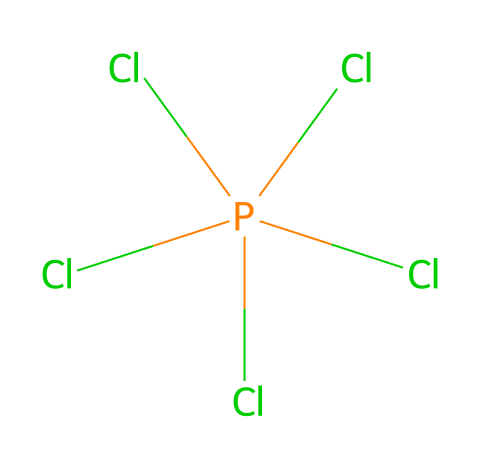What is the molecular formula of phosphorus pentachloride? The SMILES representation indicates that there is one phosphorus atom and five chlorine atoms. Therefore, the molecular formula is derived from counting these atoms.
Answer: PCl5 How many chlorine atoms are attached to the phosphorus atom? By analyzing the structure given in the SMILES notation, the phosphorus atom is bonded to five chlorine atoms, which can be seen through the representation.
Answer: five What type of hybridization does the phosphorus atom exhibit? Phosphorus in PCl5 undergoes sp3d hybridization to accommodate five bonded pairs of electrons, as evident from its bonds to chlorine.
Answer: sp3d Is phosphorus pentachloride a hypervalent compound? The presence of more than four bonds around the phosphorus atom, with five bonds here, confirms that it is hypervalent, which is a characteristic of its classification.
Answer: yes What is the geometric shape of phosphorus pentachloride? The five bonded pairs around phosphorus result in a trigonal bipyramidal geometry, which is typical for compounds with this hybridization and bonding pattern.
Answer: trigonal bipyramidal What is the primary use of phosphorus pentachloride? Phosphorus pentachloride is commonly used in organic synthesis and pesticide production, which can be inferred from its applications in chemical processes.
Answer: organic synthesis and pesticide production 